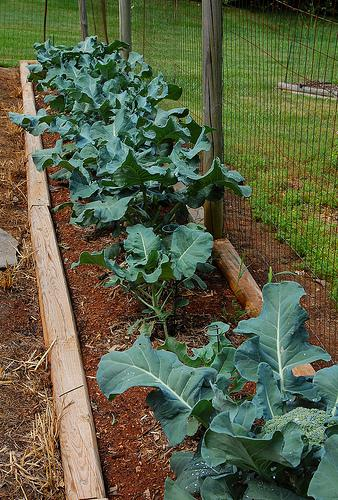Question: where was the photo taken?
Choices:
A. In a cave.
B. On a ship.
C. At a wedding.
D. In the garden.
Answer with the letter. Answer: D Question: what is the subject of the photo?
Choices:
A. The couple.
B. The ship.
C. The house.
D. The garden.
Answer with the letter. Answer: D Question: what is the color of the leafs?
Choices:
A. Brown.
B. Yellow.
C. Green.
D. Red.
Answer with the letter. Answer: C Question: when was the photo taken?
Choices:
A. At night.
B. Last week.
C. During the day.
D. Yesterday.
Answer with the letter. Answer: C 